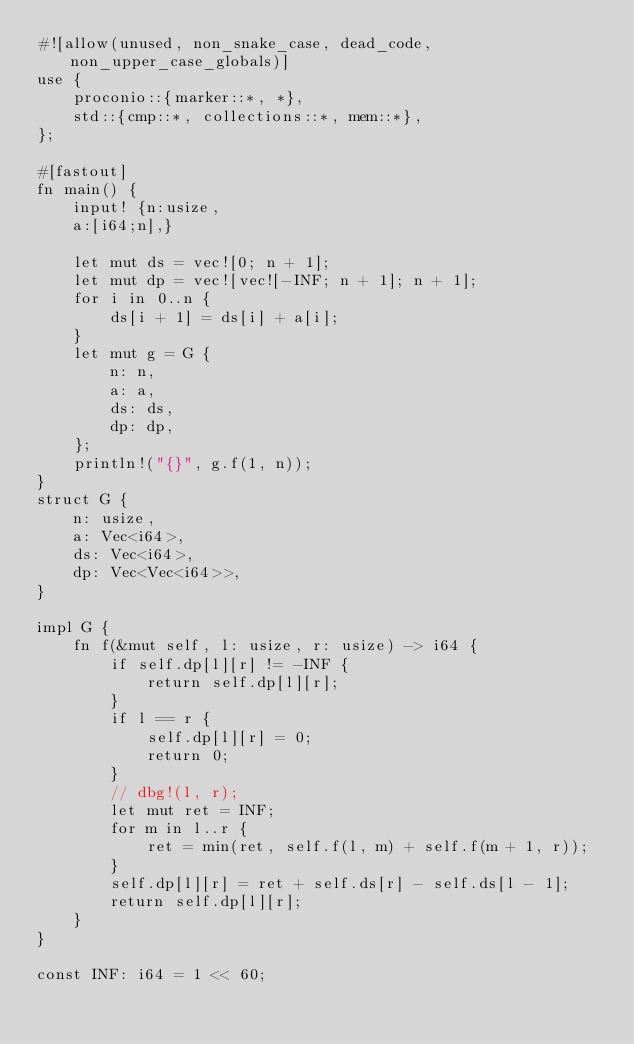<code> <loc_0><loc_0><loc_500><loc_500><_Rust_>#![allow(unused, non_snake_case, dead_code, non_upper_case_globals)]
use {
    proconio::{marker::*, *},
    std::{cmp::*, collections::*, mem::*},
};

#[fastout]
fn main() {
    input! {n:usize,
    a:[i64;n],}

    let mut ds = vec![0; n + 1];
    let mut dp = vec![vec![-INF; n + 1]; n + 1];
    for i in 0..n {
        ds[i + 1] = ds[i] + a[i];
    }
    let mut g = G {
        n: n,
        a: a,
        ds: ds,
        dp: dp,
    };
    println!("{}", g.f(1, n));
}
struct G {
    n: usize,
    a: Vec<i64>,
    ds: Vec<i64>,
    dp: Vec<Vec<i64>>,
}

impl G {
    fn f(&mut self, l: usize, r: usize) -> i64 {
        if self.dp[l][r] != -INF {
            return self.dp[l][r];
        }
        if l == r {
            self.dp[l][r] = 0;
            return 0;
        }
        // dbg!(l, r);
        let mut ret = INF;
        for m in l..r {
            ret = min(ret, self.f(l, m) + self.f(m + 1, r));
        }
        self.dp[l][r] = ret + self.ds[r] - self.ds[l - 1];
        return self.dp[l][r];
    }
}

const INF: i64 = 1 << 60;
</code> 